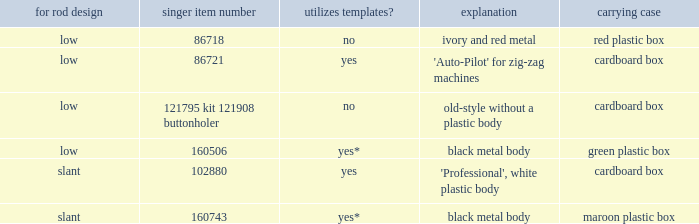What's the storage case of the buttonholer described as ivory and red metal? Red plastic box. 